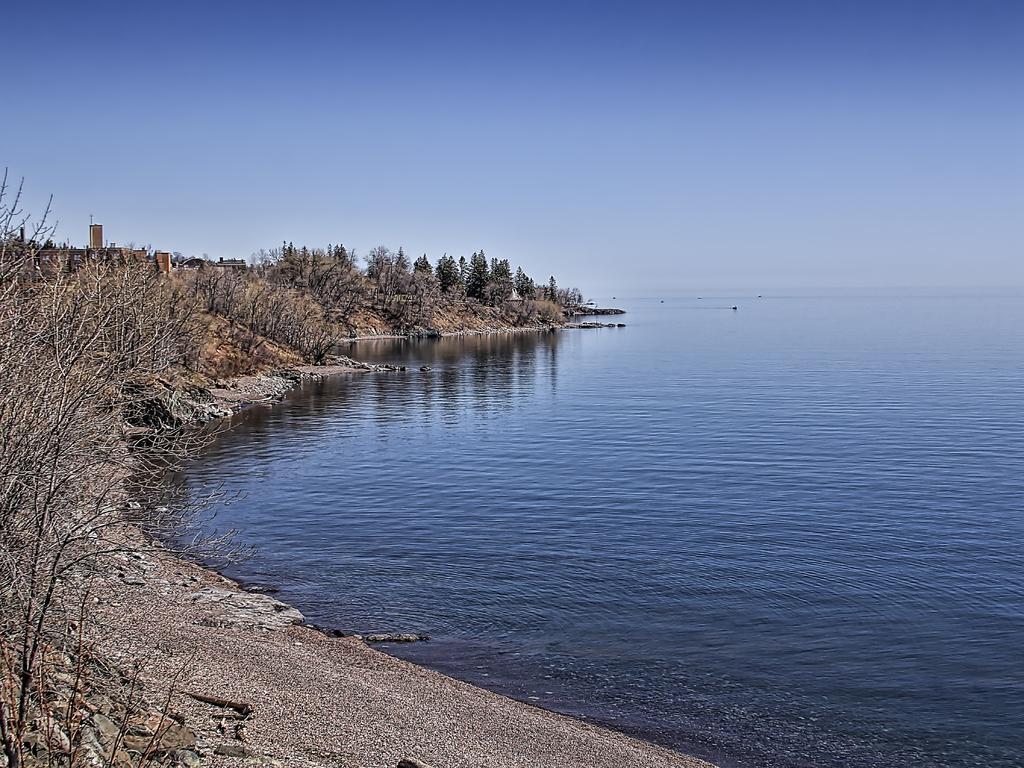In one or two sentences, can you explain what this image depicts? In this image I can see few trees and the water. The sky is in blue and white color. 